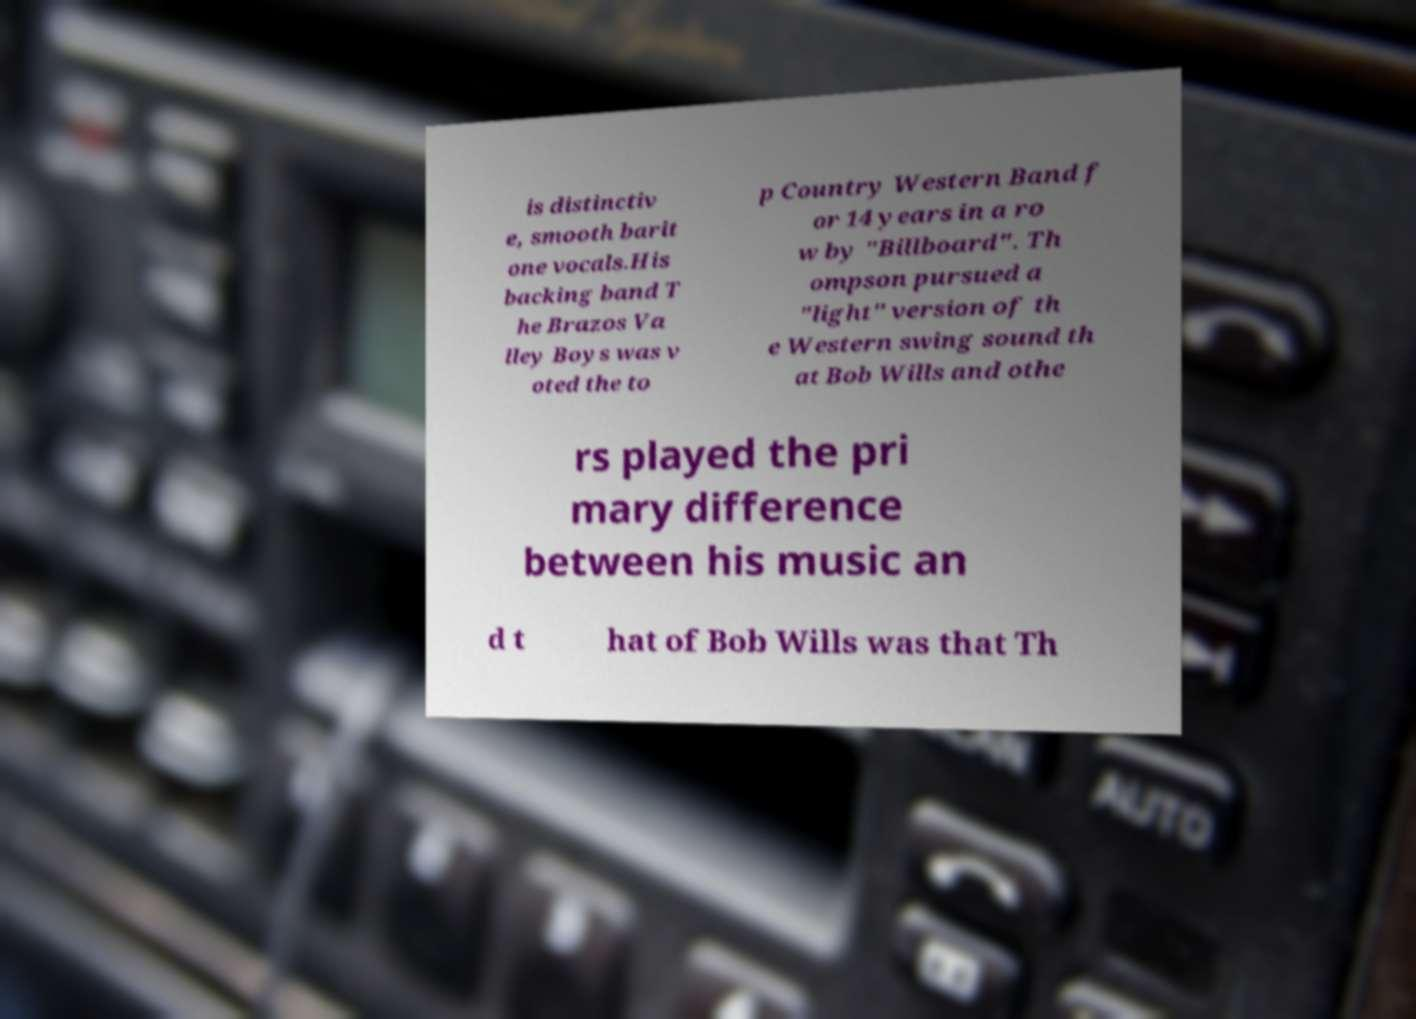Could you extract and type out the text from this image? is distinctiv e, smooth barit one vocals.His backing band T he Brazos Va lley Boys was v oted the to p Country Western Band f or 14 years in a ro w by "Billboard". Th ompson pursued a "light" version of th e Western swing sound th at Bob Wills and othe rs played the pri mary difference between his music an d t hat of Bob Wills was that Th 